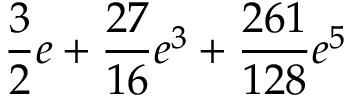<formula> <loc_0><loc_0><loc_500><loc_500>\frac { 3 } { 2 } e + \frac { 2 7 } { 1 6 } e ^ { 3 } + \frac { 2 6 1 } { 1 2 8 } e ^ { 5 }</formula> 